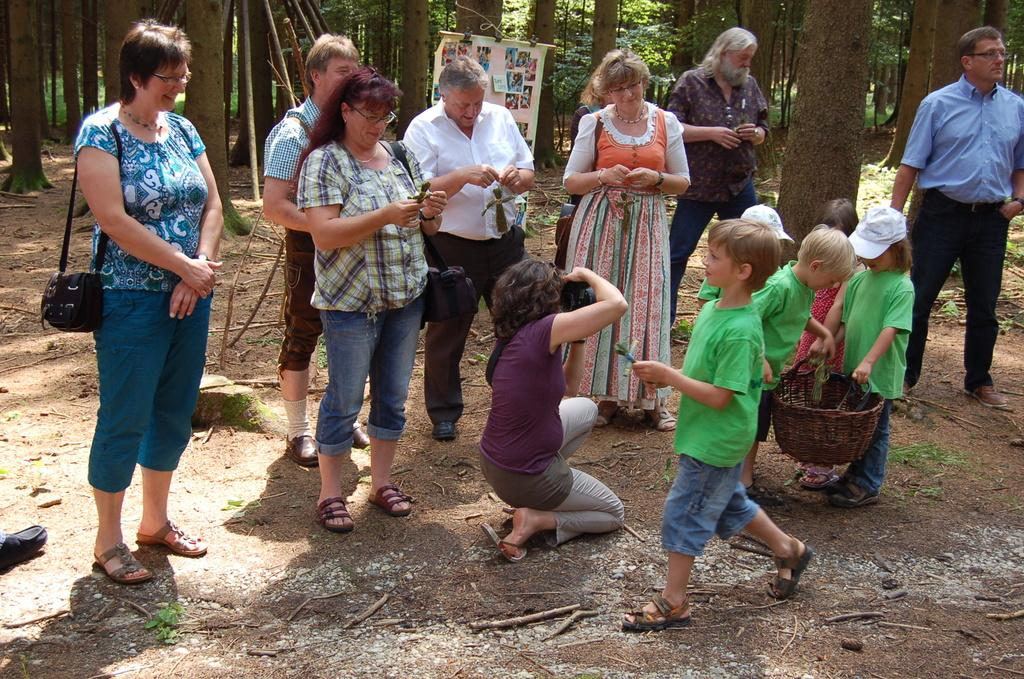What is happening in the image involving a group of people? There is a group of people in the image, but their specific activity is not clear. What is the kid holding in the image? The kid is holding a basket in the image. What is the person with the camera likely doing? The person holding a camera is likely taking pictures or documenting the event. What can be seen in the background of the image? There are pictures and trees in the background of the image. What type of calculator is being used by the person holding a camera in the image? There is no calculator present in the image; the person is holding a camera. What is being served for dinner in the image? There is no dinner or food being served in the image. 